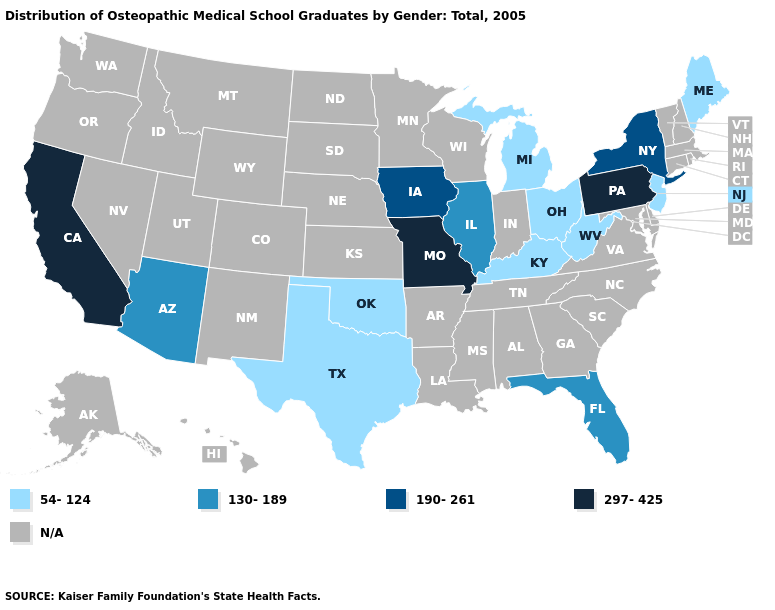What is the value of Mississippi?
Write a very short answer. N/A. Does Arizona have the lowest value in the West?
Answer briefly. Yes. Does Pennsylvania have the lowest value in the Northeast?
Quick response, please. No. Among the states that border Oklahoma , does Missouri have the lowest value?
Short answer required. No. Name the states that have a value in the range 130-189?
Keep it brief. Arizona, Florida, Illinois. Name the states that have a value in the range 190-261?
Keep it brief. Iowa, New York. What is the value of Alaska?
Short answer required. N/A. What is the highest value in the West ?
Keep it brief. 297-425. What is the value of Wyoming?
Give a very brief answer. N/A. What is the value of New York?
Write a very short answer. 190-261. Which states have the lowest value in the West?
Answer briefly. Arizona. What is the lowest value in the West?
Short answer required. 130-189. What is the highest value in the West ?
Quick response, please. 297-425. What is the highest value in states that border California?
Keep it brief. 130-189. Is the legend a continuous bar?
Quick response, please. No. 